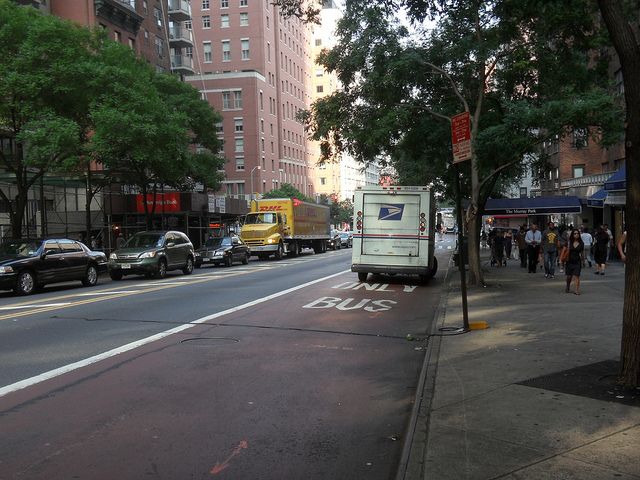Extract all visible text content from this image. ONLY BUS 